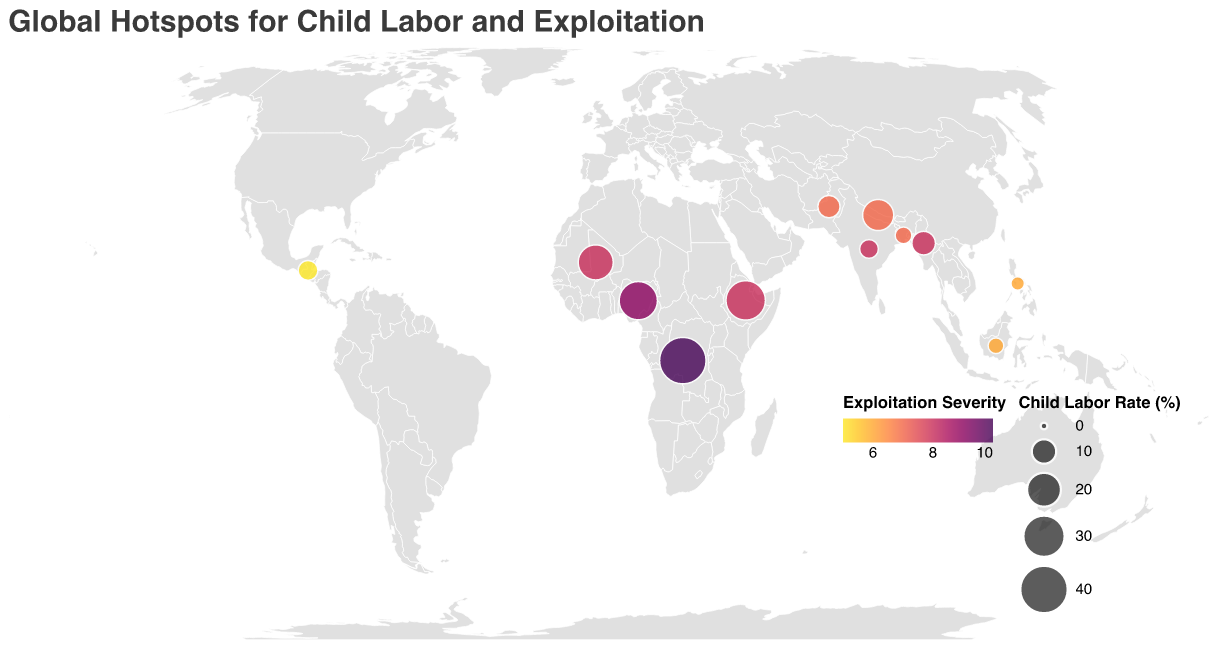What's the title of the figure? The title is visually prominent, generally placed at the top of a figure, and often in a larger or distinct font size for clarity.
Answer: Global Hotspots for Child Labor and Exploitation What region does Nigeria belong to? Regions are typically labeled in a plot's tooltip, accessible by hovering over data points or from the plot legend when interacting with data points.
Answer: West Africa Which country has the highest child labor rate? Looking at the size of the circles, the largest circle representation indicates the highest child labor rate. The tooltip data can further confirm the exact value.
Answer: Democratic Republic of Congo Compare the child labor rate between Mali and India. Which is higher? By inspecting the sizes of the circles representing Mali and India or checking their values through tooltips, we can discern and compare them.
Answer: Mali What is the exploitation severity of Bangladesh? This information is provided in the tooltip that appears when hovering over the circle representing Bangladesh in the plot.
Answer: 7 Identify the countries with a child labor rate lower than 5%. To find this, we need to check all circles of smaller sizes and verify their child labor rates using the tooltips.
Answer: Bangladesh, Philippines, Indonesia Among the countries in Southeast Asia, which has the lowest exploitation severity? We inspect the colors of the circles for countries in Southeast Asia and use the tooltips to identify the country with the lowest severity indicator.
Answer: Philippines and Indonesia What is the average child labor rate for countries in South Asia? Identify the countries in South Asia, sum their child labor rates, and divide by the number of these countries. Calculations: (5.6 + 4.3 + 8.2 + 16.8) / 4 = 34.9 / 4 = 8.725.
Answer: 8.725 Which country is marked with the harshest exploitation severity? By identifying the country with the darkest color in the color spectrum representing severity, we can find the harshest exploitation severity level.
Answer: Democratic Republic of Congo What is the sum of exploitation severity for countries in Southeast Asia? Locate and sum the exploitation severity values for Myanmar, Philippines, and Indonesia from the tooltips: 8 + 6 + 6 = 20.
Answer: 20 